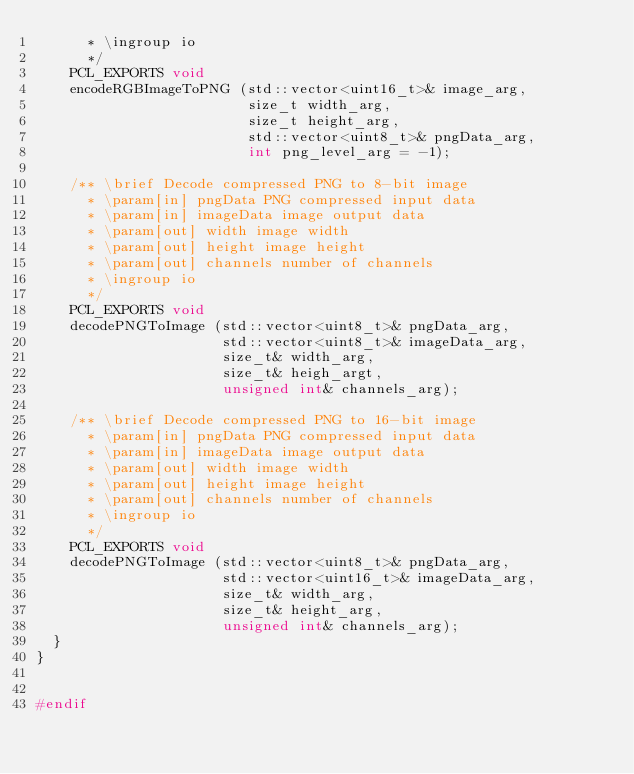<code> <loc_0><loc_0><loc_500><loc_500><_C_>      * \ingroup io
      */
    PCL_EXPORTS void
    encodeRGBImageToPNG (std::vector<uint16_t>& image_arg,
                         size_t width_arg,
                         size_t height_arg,
                         std::vector<uint8_t>& pngData_arg,
                         int png_level_arg = -1);

    /** \brief Decode compressed PNG to 8-bit image
      * \param[in] pngData PNG compressed input data
      * \param[in] imageData image output data
      * \param[out] width image width
      * \param[out] height image height
      * \param[out] channels number of channels
      * \ingroup io
      */
    PCL_EXPORTS void
    decodePNGToImage (std::vector<uint8_t>& pngData_arg,
                      std::vector<uint8_t>& imageData_arg,
                      size_t& width_arg,
                      size_t& heigh_argt,
                      unsigned int& channels_arg);

    /** \brief Decode compressed PNG to 16-bit image
      * \param[in] pngData PNG compressed input data
      * \param[in] imageData image output data
      * \param[out] width image width
      * \param[out] height image height
      * \param[out] channels number of channels
      * \ingroup io
      */
    PCL_EXPORTS void
    decodePNGToImage (std::vector<uint8_t>& pngData_arg,
                      std::vector<uint16_t>& imageData_arg,
                      size_t& width_arg,
                      size_t& height_arg,
                      unsigned int& channels_arg);
  }
}


#endif

</code> 